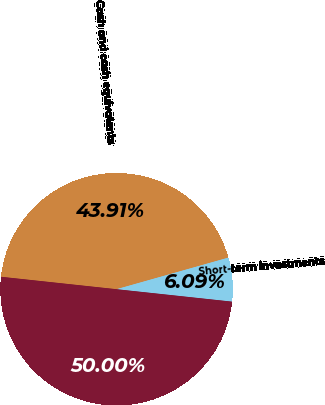<chart> <loc_0><loc_0><loc_500><loc_500><pie_chart><fcel>Cash and cash equivalents<fcel>Short-term investments<fcel>Cash cash equivalents and<nl><fcel>43.91%<fcel>6.09%<fcel>50.0%<nl></chart> 